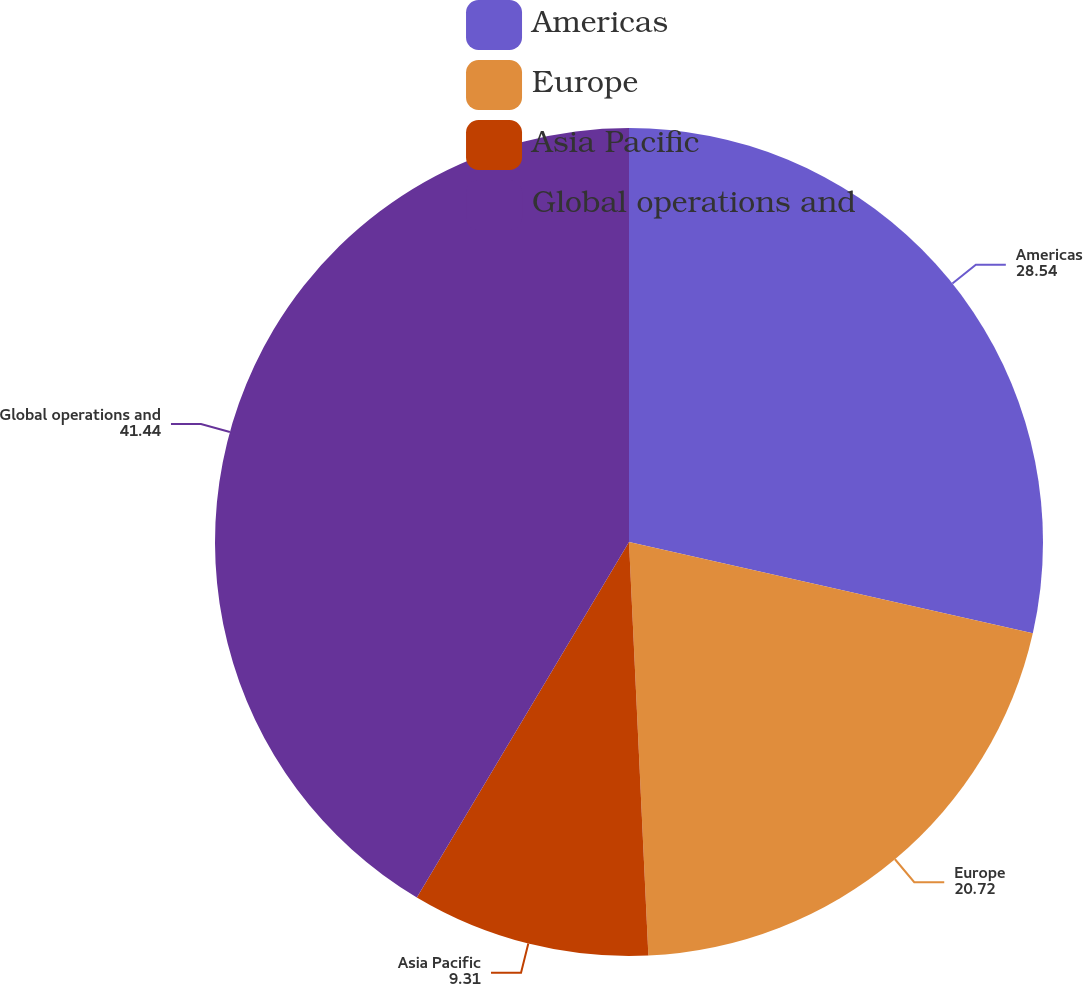<chart> <loc_0><loc_0><loc_500><loc_500><pie_chart><fcel>Americas<fcel>Europe<fcel>Asia Pacific<fcel>Global operations and<nl><fcel>28.54%<fcel>20.72%<fcel>9.31%<fcel>41.44%<nl></chart> 